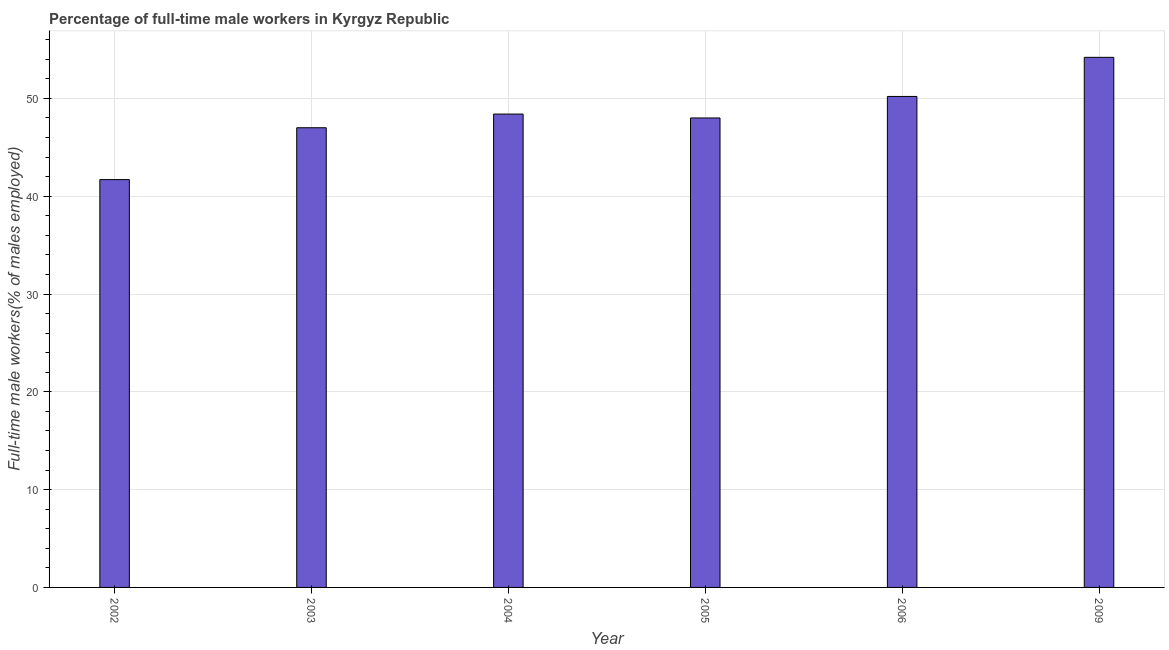Does the graph contain any zero values?
Offer a terse response. No. What is the title of the graph?
Your answer should be very brief. Percentage of full-time male workers in Kyrgyz Republic. What is the label or title of the X-axis?
Give a very brief answer. Year. What is the label or title of the Y-axis?
Give a very brief answer. Full-time male workers(% of males employed). What is the percentage of full-time male workers in 2009?
Keep it short and to the point. 54.2. Across all years, what is the maximum percentage of full-time male workers?
Offer a terse response. 54.2. Across all years, what is the minimum percentage of full-time male workers?
Provide a short and direct response. 41.7. In which year was the percentage of full-time male workers maximum?
Your answer should be very brief. 2009. In which year was the percentage of full-time male workers minimum?
Your answer should be very brief. 2002. What is the sum of the percentage of full-time male workers?
Provide a short and direct response. 289.5. What is the average percentage of full-time male workers per year?
Offer a very short reply. 48.25. What is the median percentage of full-time male workers?
Your answer should be compact. 48.2. In how many years, is the percentage of full-time male workers greater than 4 %?
Your answer should be compact. 6. What is the ratio of the percentage of full-time male workers in 2002 to that in 2004?
Provide a short and direct response. 0.86. Is the difference between the percentage of full-time male workers in 2003 and 2005 greater than the difference between any two years?
Make the answer very short. No. What is the difference between the highest and the second highest percentage of full-time male workers?
Provide a succinct answer. 4. Is the sum of the percentage of full-time male workers in 2005 and 2006 greater than the maximum percentage of full-time male workers across all years?
Provide a succinct answer. Yes. What is the difference between the highest and the lowest percentage of full-time male workers?
Your answer should be very brief. 12.5. In how many years, is the percentage of full-time male workers greater than the average percentage of full-time male workers taken over all years?
Provide a short and direct response. 3. How many bars are there?
Ensure brevity in your answer.  6. Are all the bars in the graph horizontal?
Your answer should be very brief. No. What is the Full-time male workers(% of males employed) in 2002?
Offer a terse response. 41.7. What is the Full-time male workers(% of males employed) of 2003?
Keep it short and to the point. 47. What is the Full-time male workers(% of males employed) of 2004?
Your answer should be very brief. 48.4. What is the Full-time male workers(% of males employed) of 2006?
Give a very brief answer. 50.2. What is the Full-time male workers(% of males employed) in 2009?
Provide a short and direct response. 54.2. What is the difference between the Full-time male workers(% of males employed) in 2002 and 2003?
Offer a terse response. -5.3. What is the difference between the Full-time male workers(% of males employed) in 2003 and 2005?
Offer a very short reply. -1. What is the difference between the Full-time male workers(% of males employed) in 2003 and 2006?
Your response must be concise. -3.2. What is the difference between the Full-time male workers(% of males employed) in 2004 and 2006?
Provide a short and direct response. -1.8. What is the difference between the Full-time male workers(% of males employed) in 2004 and 2009?
Offer a terse response. -5.8. What is the difference between the Full-time male workers(% of males employed) in 2005 and 2006?
Your answer should be very brief. -2.2. What is the difference between the Full-time male workers(% of males employed) in 2005 and 2009?
Your answer should be compact. -6.2. What is the difference between the Full-time male workers(% of males employed) in 2006 and 2009?
Offer a terse response. -4. What is the ratio of the Full-time male workers(% of males employed) in 2002 to that in 2003?
Ensure brevity in your answer.  0.89. What is the ratio of the Full-time male workers(% of males employed) in 2002 to that in 2004?
Offer a very short reply. 0.86. What is the ratio of the Full-time male workers(% of males employed) in 2002 to that in 2005?
Your answer should be compact. 0.87. What is the ratio of the Full-time male workers(% of males employed) in 2002 to that in 2006?
Offer a very short reply. 0.83. What is the ratio of the Full-time male workers(% of males employed) in 2002 to that in 2009?
Keep it short and to the point. 0.77. What is the ratio of the Full-time male workers(% of males employed) in 2003 to that in 2004?
Your response must be concise. 0.97. What is the ratio of the Full-time male workers(% of males employed) in 2003 to that in 2006?
Give a very brief answer. 0.94. What is the ratio of the Full-time male workers(% of males employed) in 2003 to that in 2009?
Keep it short and to the point. 0.87. What is the ratio of the Full-time male workers(% of males employed) in 2004 to that in 2005?
Provide a short and direct response. 1.01. What is the ratio of the Full-time male workers(% of males employed) in 2004 to that in 2009?
Your answer should be very brief. 0.89. What is the ratio of the Full-time male workers(% of males employed) in 2005 to that in 2006?
Provide a short and direct response. 0.96. What is the ratio of the Full-time male workers(% of males employed) in 2005 to that in 2009?
Provide a short and direct response. 0.89. What is the ratio of the Full-time male workers(% of males employed) in 2006 to that in 2009?
Make the answer very short. 0.93. 